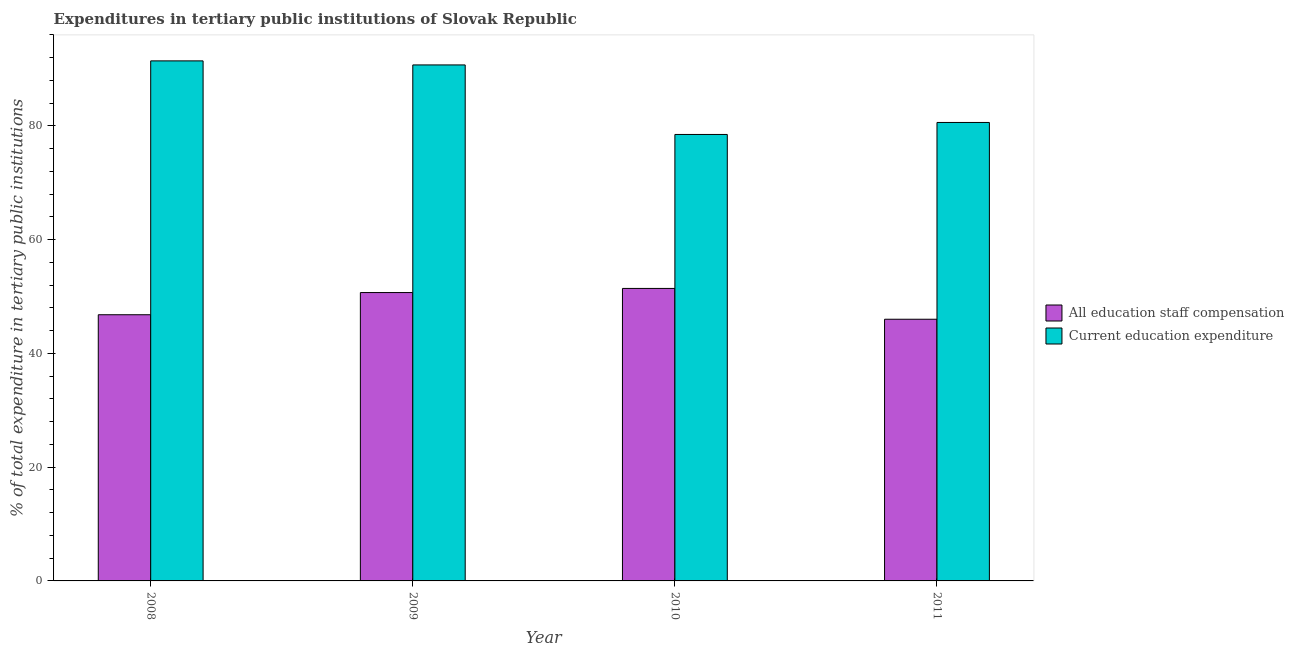How many groups of bars are there?
Offer a terse response. 4. Are the number of bars on each tick of the X-axis equal?
Provide a succinct answer. Yes. How many bars are there on the 3rd tick from the right?
Ensure brevity in your answer.  2. What is the label of the 3rd group of bars from the left?
Provide a short and direct response. 2010. What is the expenditure in staff compensation in 2008?
Your response must be concise. 46.81. Across all years, what is the maximum expenditure in staff compensation?
Provide a succinct answer. 51.43. Across all years, what is the minimum expenditure in staff compensation?
Offer a terse response. 46.01. What is the total expenditure in staff compensation in the graph?
Provide a short and direct response. 194.96. What is the difference between the expenditure in education in 2008 and that in 2009?
Make the answer very short. 0.71. What is the difference between the expenditure in education in 2008 and the expenditure in staff compensation in 2009?
Provide a succinct answer. 0.71. What is the average expenditure in staff compensation per year?
Your answer should be compact. 48.74. What is the ratio of the expenditure in education in 2008 to that in 2009?
Your response must be concise. 1.01. Is the expenditure in education in 2008 less than that in 2011?
Keep it short and to the point. No. What is the difference between the highest and the second highest expenditure in education?
Make the answer very short. 0.71. What is the difference between the highest and the lowest expenditure in staff compensation?
Offer a terse response. 5.42. In how many years, is the expenditure in staff compensation greater than the average expenditure in staff compensation taken over all years?
Provide a succinct answer. 2. Is the sum of the expenditure in education in 2008 and 2009 greater than the maximum expenditure in staff compensation across all years?
Ensure brevity in your answer.  Yes. What does the 1st bar from the left in 2008 represents?
Make the answer very short. All education staff compensation. What does the 1st bar from the right in 2010 represents?
Offer a terse response. Current education expenditure. How many bars are there?
Keep it short and to the point. 8. Are all the bars in the graph horizontal?
Provide a succinct answer. No. Where does the legend appear in the graph?
Your answer should be very brief. Center right. What is the title of the graph?
Keep it short and to the point. Expenditures in tertiary public institutions of Slovak Republic. Does "Food and tobacco" appear as one of the legend labels in the graph?
Your answer should be compact. No. What is the label or title of the Y-axis?
Provide a short and direct response. % of total expenditure in tertiary public institutions. What is the % of total expenditure in tertiary public institutions in All education staff compensation in 2008?
Give a very brief answer. 46.81. What is the % of total expenditure in tertiary public institutions in Current education expenditure in 2008?
Your response must be concise. 91.44. What is the % of total expenditure in tertiary public institutions in All education staff compensation in 2009?
Give a very brief answer. 50.71. What is the % of total expenditure in tertiary public institutions in Current education expenditure in 2009?
Your answer should be very brief. 90.73. What is the % of total expenditure in tertiary public institutions in All education staff compensation in 2010?
Make the answer very short. 51.43. What is the % of total expenditure in tertiary public institutions in Current education expenditure in 2010?
Offer a very short reply. 78.51. What is the % of total expenditure in tertiary public institutions of All education staff compensation in 2011?
Keep it short and to the point. 46.01. What is the % of total expenditure in tertiary public institutions in Current education expenditure in 2011?
Your response must be concise. 80.62. Across all years, what is the maximum % of total expenditure in tertiary public institutions of All education staff compensation?
Keep it short and to the point. 51.43. Across all years, what is the maximum % of total expenditure in tertiary public institutions of Current education expenditure?
Provide a succinct answer. 91.44. Across all years, what is the minimum % of total expenditure in tertiary public institutions in All education staff compensation?
Make the answer very short. 46.01. Across all years, what is the minimum % of total expenditure in tertiary public institutions of Current education expenditure?
Your answer should be very brief. 78.51. What is the total % of total expenditure in tertiary public institutions of All education staff compensation in the graph?
Provide a short and direct response. 194.96. What is the total % of total expenditure in tertiary public institutions of Current education expenditure in the graph?
Provide a short and direct response. 341.3. What is the difference between the % of total expenditure in tertiary public institutions in All education staff compensation in 2008 and that in 2009?
Your response must be concise. -3.9. What is the difference between the % of total expenditure in tertiary public institutions in Current education expenditure in 2008 and that in 2009?
Provide a succinct answer. 0.71. What is the difference between the % of total expenditure in tertiary public institutions in All education staff compensation in 2008 and that in 2010?
Offer a very short reply. -4.62. What is the difference between the % of total expenditure in tertiary public institutions in Current education expenditure in 2008 and that in 2010?
Give a very brief answer. 12.94. What is the difference between the % of total expenditure in tertiary public institutions in All education staff compensation in 2008 and that in 2011?
Keep it short and to the point. 0.79. What is the difference between the % of total expenditure in tertiary public institutions in Current education expenditure in 2008 and that in 2011?
Your answer should be compact. 10.83. What is the difference between the % of total expenditure in tertiary public institutions of All education staff compensation in 2009 and that in 2010?
Your response must be concise. -0.73. What is the difference between the % of total expenditure in tertiary public institutions in Current education expenditure in 2009 and that in 2010?
Provide a succinct answer. 12.23. What is the difference between the % of total expenditure in tertiary public institutions in All education staff compensation in 2009 and that in 2011?
Offer a very short reply. 4.69. What is the difference between the % of total expenditure in tertiary public institutions in Current education expenditure in 2009 and that in 2011?
Keep it short and to the point. 10.12. What is the difference between the % of total expenditure in tertiary public institutions in All education staff compensation in 2010 and that in 2011?
Provide a short and direct response. 5.42. What is the difference between the % of total expenditure in tertiary public institutions of Current education expenditure in 2010 and that in 2011?
Your answer should be very brief. -2.11. What is the difference between the % of total expenditure in tertiary public institutions in All education staff compensation in 2008 and the % of total expenditure in tertiary public institutions in Current education expenditure in 2009?
Your answer should be very brief. -43.93. What is the difference between the % of total expenditure in tertiary public institutions in All education staff compensation in 2008 and the % of total expenditure in tertiary public institutions in Current education expenditure in 2010?
Offer a terse response. -31.7. What is the difference between the % of total expenditure in tertiary public institutions in All education staff compensation in 2008 and the % of total expenditure in tertiary public institutions in Current education expenditure in 2011?
Your response must be concise. -33.81. What is the difference between the % of total expenditure in tertiary public institutions of All education staff compensation in 2009 and the % of total expenditure in tertiary public institutions of Current education expenditure in 2010?
Your answer should be compact. -27.8. What is the difference between the % of total expenditure in tertiary public institutions in All education staff compensation in 2009 and the % of total expenditure in tertiary public institutions in Current education expenditure in 2011?
Your answer should be very brief. -29.91. What is the difference between the % of total expenditure in tertiary public institutions in All education staff compensation in 2010 and the % of total expenditure in tertiary public institutions in Current education expenditure in 2011?
Offer a very short reply. -29.18. What is the average % of total expenditure in tertiary public institutions in All education staff compensation per year?
Your response must be concise. 48.74. What is the average % of total expenditure in tertiary public institutions in Current education expenditure per year?
Provide a succinct answer. 85.33. In the year 2008, what is the difference between the % of total expenditure in tertiary public institutions of All education staff compensation and % of total expenditure in tertiary public institutions of Current education expenditure?
Give a very brief answer. -44.64. In the year 2009, what is the difference between the % of total expenditure in tertiary public institutions of All education staff compensation and % of total expenditure in tertiary public institutions of Current education expenditure?
Your answer should be very brief. -40.03. In the year 2010, what is the difference between the % of total expenditure in tertiary public institutions of All education staff compensation and % of total expenditure in tertiary public institutions of Current education expenditure?
Keep it short and to the point. -27.08. In the year 2011, what is the difference between the % of total expenditure in tertiary public institutions of All education staff compensation and % of total expenditure in tertiary public institutions of Current education expenditure?
Your answer should be very brief. -34.6. What is the ratio of the % of total expenditure in tertiary public institutions in Current education expenditure in 2008 to that in 2009?
Keep it short and to the point. 1.01. What is the ratio of the % of total expenditure in tertiary public institutions of All education staff compensation in 2008 to that in 2010?
Ensure brevity in your answer.  0.91. What is the ratio of the % of total expenditure in tertiary public institutions of Current education expenditure in 2008 to that in 2010?
Keep it short and to the point. 1.16. What is the ratio of the % of total expenditure in tertiary public institutions of All education staff compensation in 2008 to that in 2011?
Give a very brief answer. 1.02. What is the ratio of the % of total expenditure in tertiary public institutions in Current education expenditure in 2008 to that in 2011?
Provide a succinct answer. 1.13. What is the ratio of the % of total expenditure in tertiary public institutions in All education staff compensation in 2009 to that in 2010?
Offer a very short reply. 0.99. What is the ratio of the % of total expenditure in tertiary public institutions in Current education expenditure in 2009 to that in 2010?
Provide a succinct answer. 1.16. What is the ratio of the % of total expenditure in tertiary public institutions of All education staff compensation in 2009 to that in 2011?
Offer a terse response. 1.1. What is the ratio of the % of total expenditure in tertiary public institutions in Current education expenditure in 2009 to that in 2011?
Offer a terse response. 1.13. What is the ratio of the % of total expenditure in tertiary public institutions in All education staff compensation in 2010 to that in 2011?
Your answer should be compact. 1.12. What is the ratio of the % of total expenditure in tertiary public institutions of Current education expenditure in 2010 to that in 2011?
Your answer should be very brief. 0.97. What is the difference between the highest and the second highest % of total expenditure in tertiary public institutions in All education staff compensation?
Give a very brief answer. 0.73. What is the difference between the highest and the second highest % of total expenditure in tertiary public institutions of Current education expenditure?
Ensure brevity in your answer.  0.71. What is the difference between the highest and the lowest % of total expenditure in tertiary public institutions of All education staff compensation?
Provide a short and direct response. 5.42. What is the difference between the highest and the lowest % of total expenditure in tertiary public institutions in Current education expenditure?
Provide a short and direct response. 12.94. 